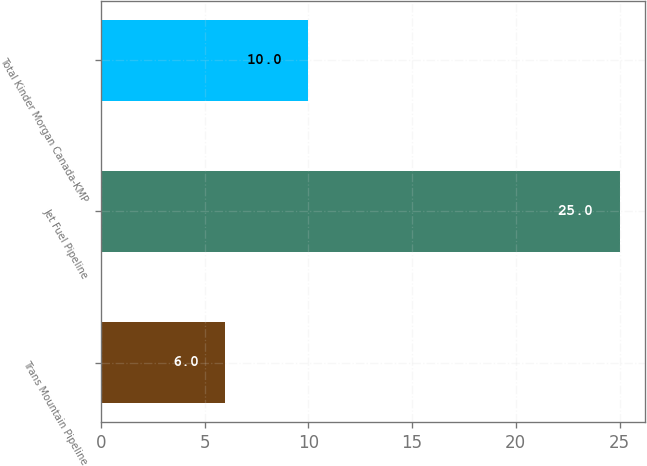Convert chart to OTSL. <chart><loc_0><loc_0><loc_500><loc_500><bar_chart><fcel>Trans Mountain Pipeline<fcel>Jet Fuel Pipeline<fcel>Total Kinder Morgan Canada-KMP<nl><fcel>6<fcel>25<fcel>10<nl></chart> 